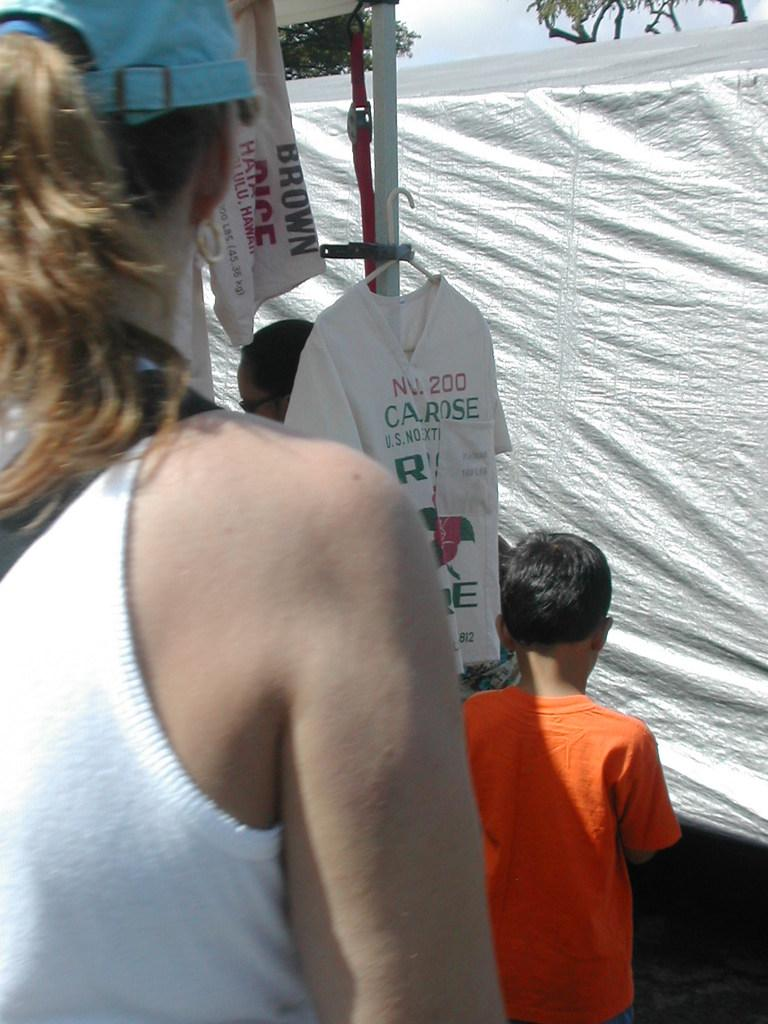Who or what can be seen in the image? There are people in the image. What is located in the center of the image? There is a pole in the center of the image. What is hanging on the pole? A T-shirt is hanged on the pole. What can be seen in the background of the image? There is a cover and trees in the background of the image. What type of society is depicted in the image? The image does not depict a society; it shows people, a pole, a T-shirt, a cover, and trees. Which country does the image represent? The image does not represent any specific country; it is a general scene with people, a pole, a T-shirt, a cover, and trees. 